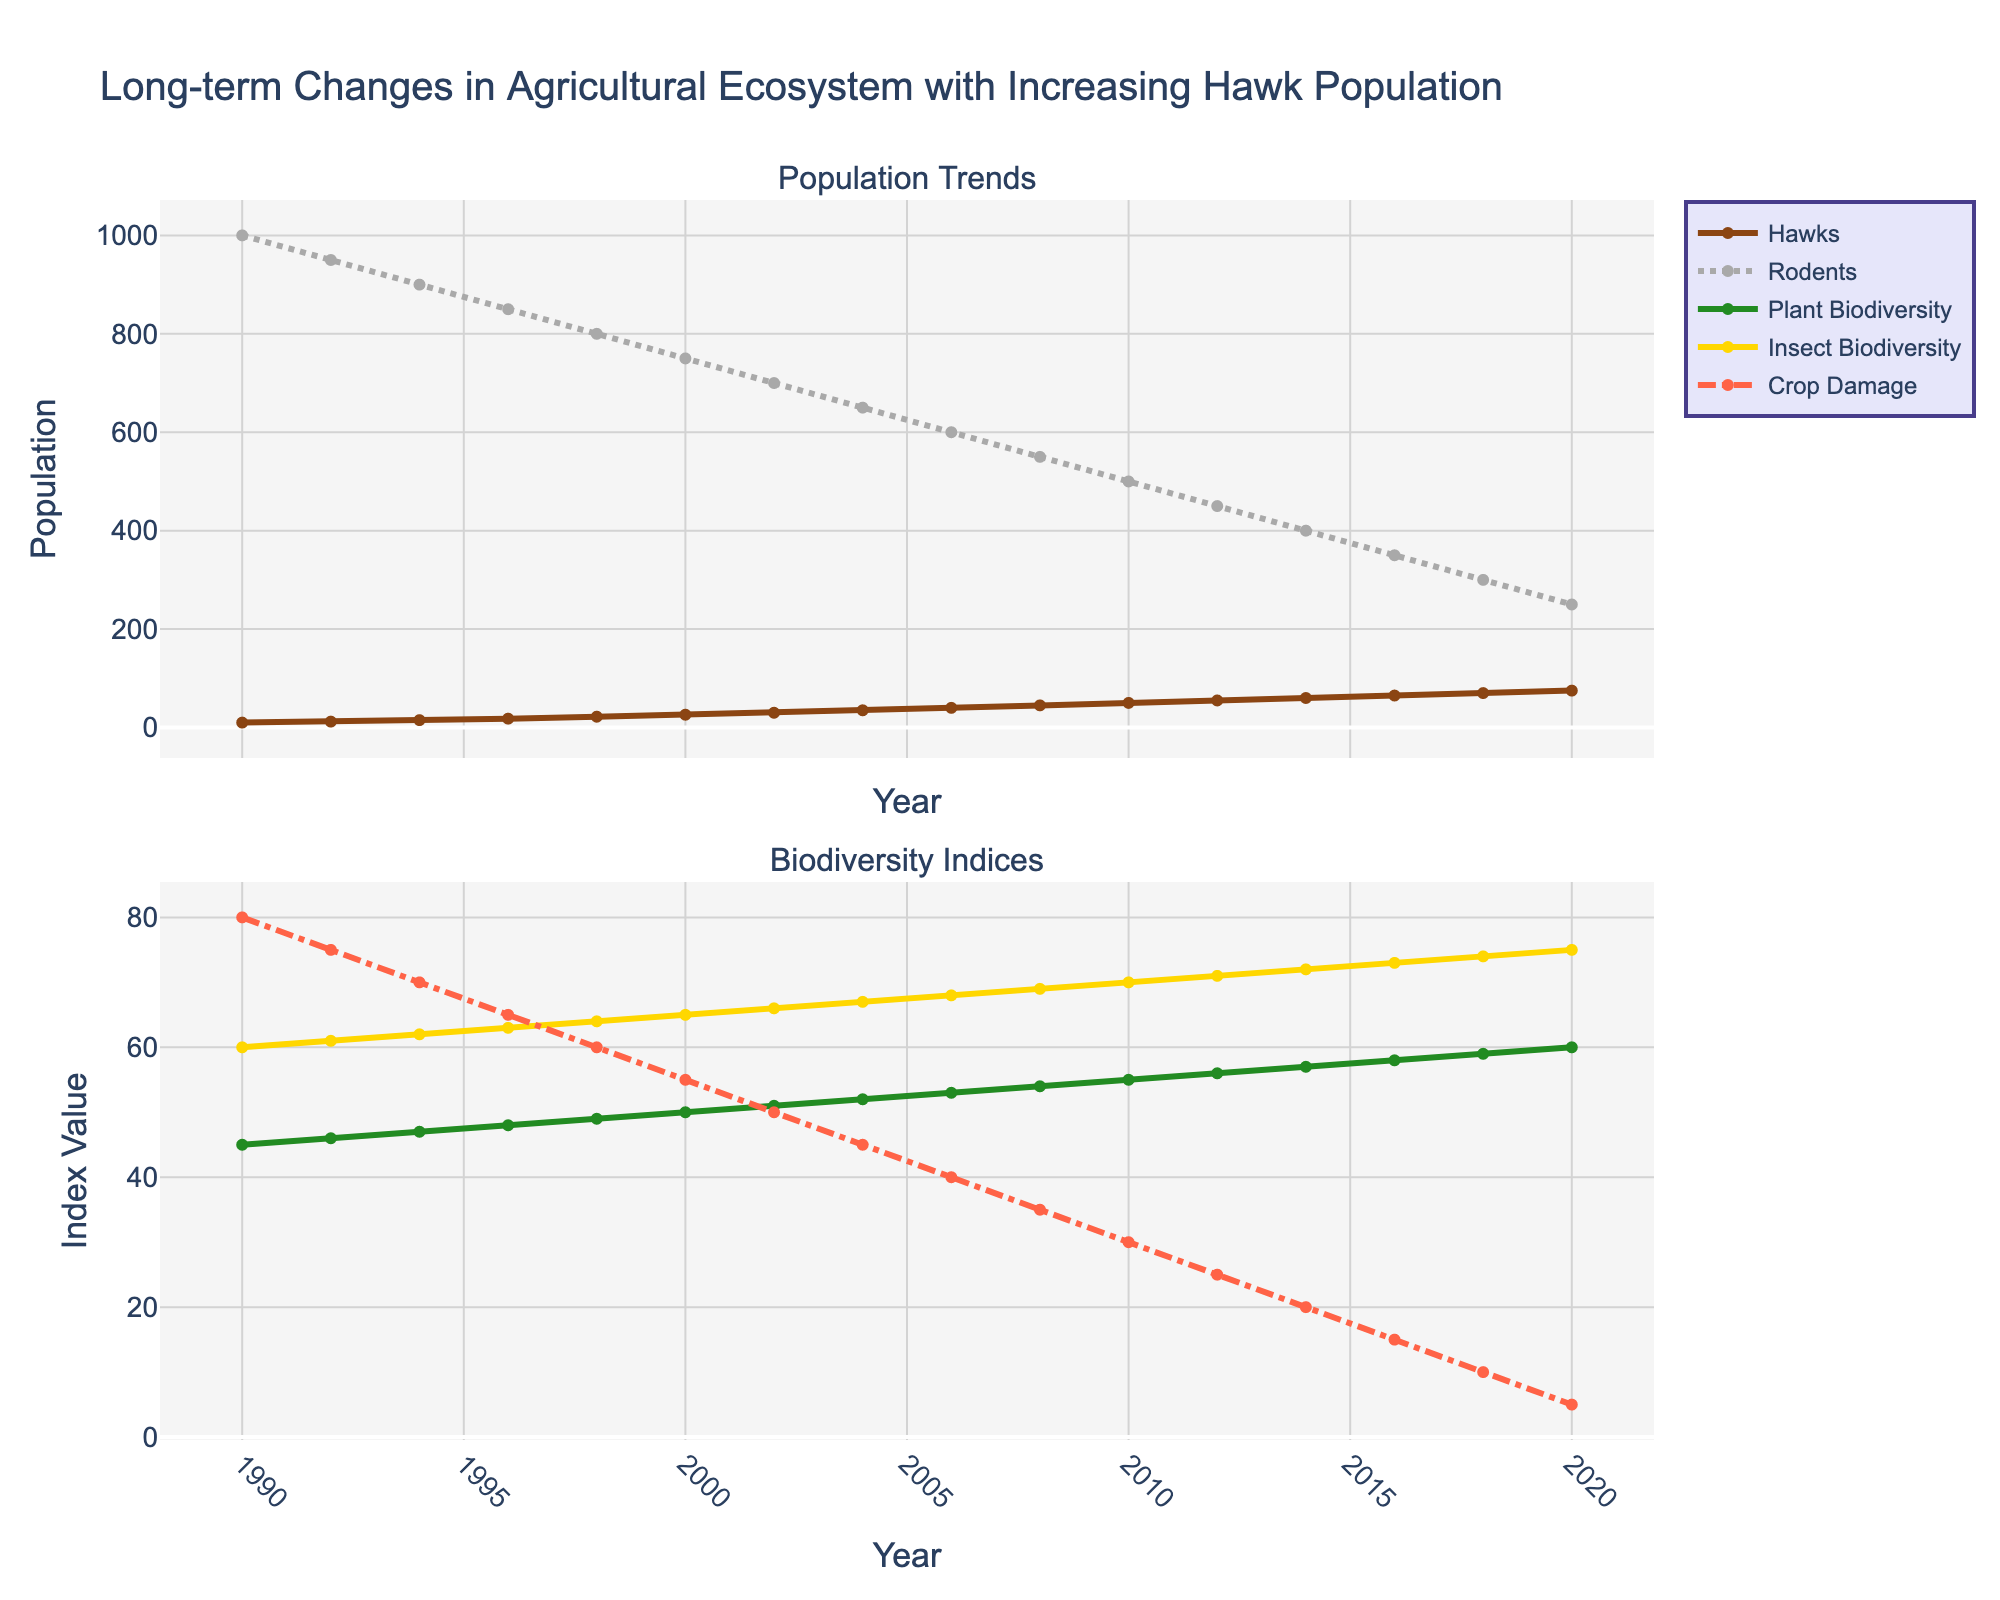How has the hawk population changed from 1990 to 2020? The hawk population increased from 10 in 1990 to 75 in 2020. The initial value is 10, and the final value is 75, so the overall change is 75 - 10 = 65.
Answer: Increased by 65 What is the trend in rodent population over the years? The rodent population shows a decreasing trend over the years. It started at 1000 in 1990 and dropped to 250 in 2020. The consistent decrease indicates a negative trend.
Answer: Decreasing trend How does the crop damage index compare to plant biodiversity index in 2008? In 2008, the crop damage index is 35, while the plant biodiversity index is 54. Comparing these values, 35 < 54.
Answer: Crop damage index is less than plant biodiversity index What is the difference between the insect biodiversity index and the plant biodiversity index in 2016? In 2016, the insect biodiversity index is 73, and the plant biodiversity index is 58. The difference is 73 - 58 = 15.
Answer: 15 How do the biodiversity indices (Plant and Insect) change as the hawk population increases? The biodiversity indices for both plants and insects show an increasing trend as the hawk population increases. The plant biodiversity index goes from 45 in 1990 to 60 in 2020, and the insect biodiversity index goes from 60 in 1990 to 75 in 2020. This suggests positive correlations with the increasing hawk population.
Answer: Increasing trend In which year did the hawk population surpass 30? Checking the data, the hawk population surpasses 30 between 2002 (30) and 2004 (35).
Answer: 2004 What can be observed about the crop damage index and rodent population relationship? Both the crop damage index and rodent population show a decreasing trend over time. For instance, as the rodent population drops from 1000 in 1990 to 250 in 2020, the crop damage index also decreases from 80 in 1990 to 5 in 2020.
Answer: Both decrease By comparing the hawk population in 2000 and 2010, how much did it increase? The hawk population in 2000 is 26, and in 2010 it is 50. The increase is calculated as 50 - 26 = 24.
Answer: Increased by 24 Which biodiversity index (Plant or Insect) has a higher value in 2012? In 2012, the plant biodiversity index is 56, and the insect biodiversity index is 71. Comparing these values, 71 > 56.
Answer: Insect biodiversity index is higher 